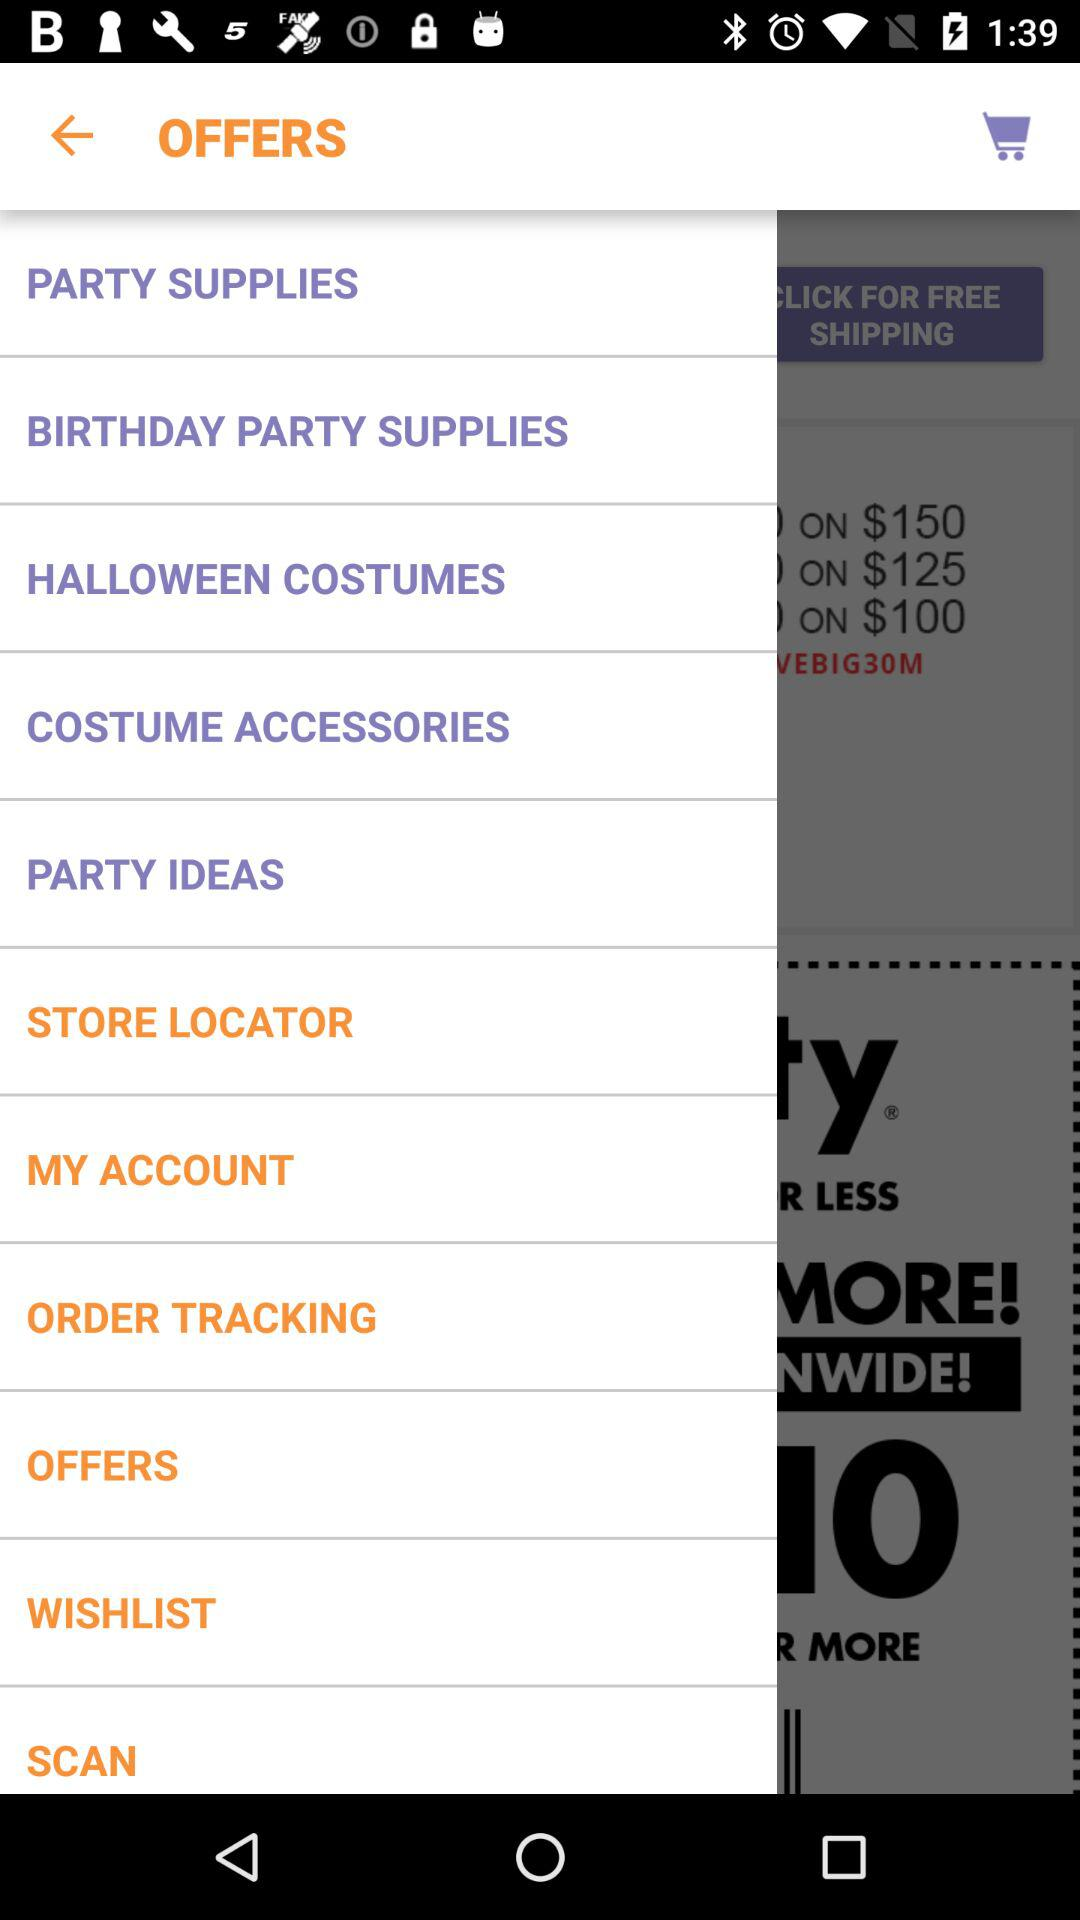Is there any item in the cart?
When the provided information is insufficient, respond with <no answer>. <no answer> 